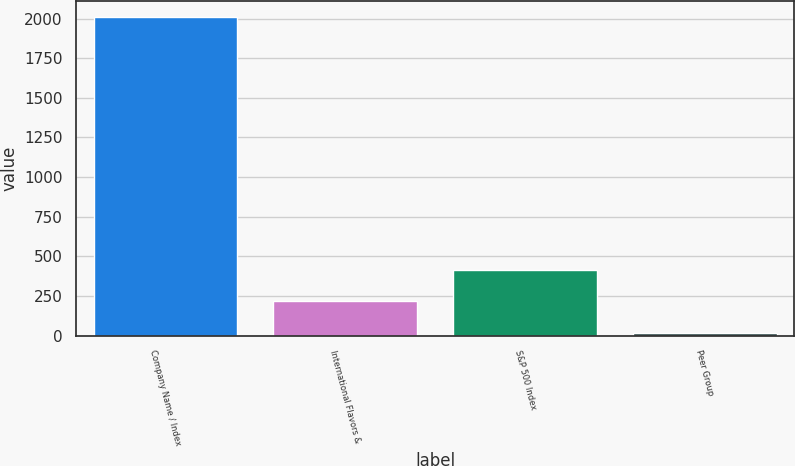<chart> <loc_0><loc_0><loc_500><loc_500><bar_chart><fcel>Company Name / Index<fcel>International Flavors &<fcel>S&P 500 Index<fcel>Peer Group<nl><fcel>2008<fcel>215.49<fcel>414.66<fcel>16.32<nl></chart> 